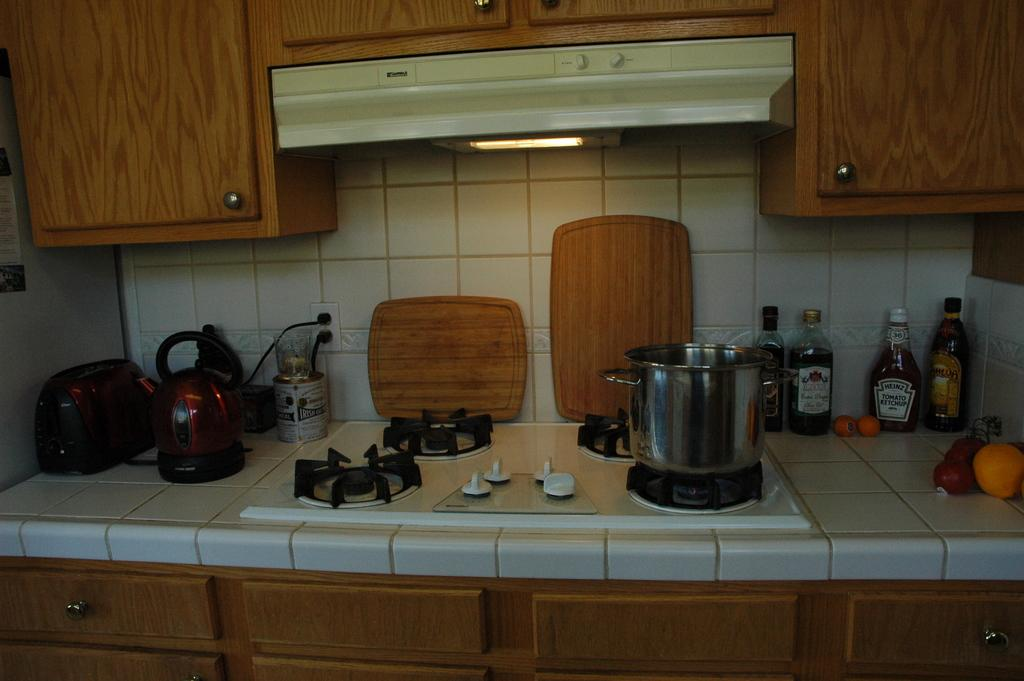Provide a one-sentence caption for the provided image. a pot is on the stove and some bottles such as heinz ketchup are on the side of the pot. 